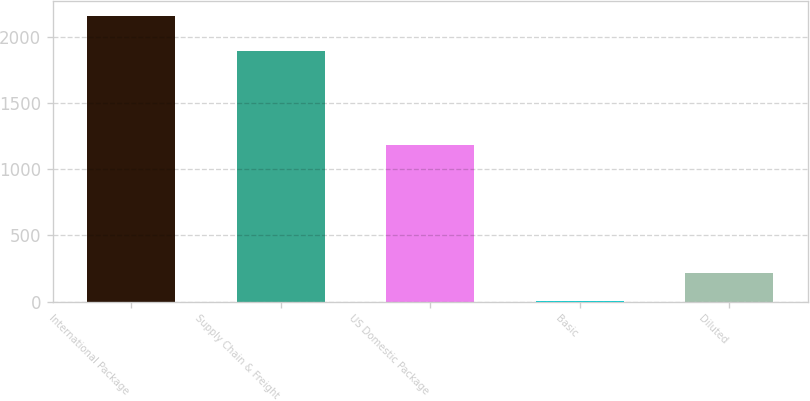Convert chart to OTSL. <chart><loc_0><loc_0><loc_500><loc_500><bar_chart><fcel>International Package<fcel>Supply Chain & Freight<fcel>US Domestic Package<fcel>Basic<fcel>Diluted<nl><fcel>2161<fcel>1897<fcel>1185<fcel>0.89<fcel>216.9<nl></chart> 